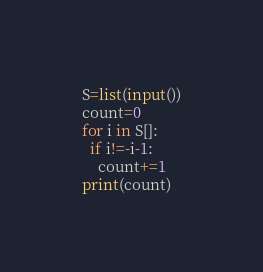Convert code to text. <code><loc_0><loc_0><loc_500><loc_500><_Python_>S=list(input())
count=0
for i in S[]:
  if i!=-i-1:
    count+=1
print(count)  </code> 